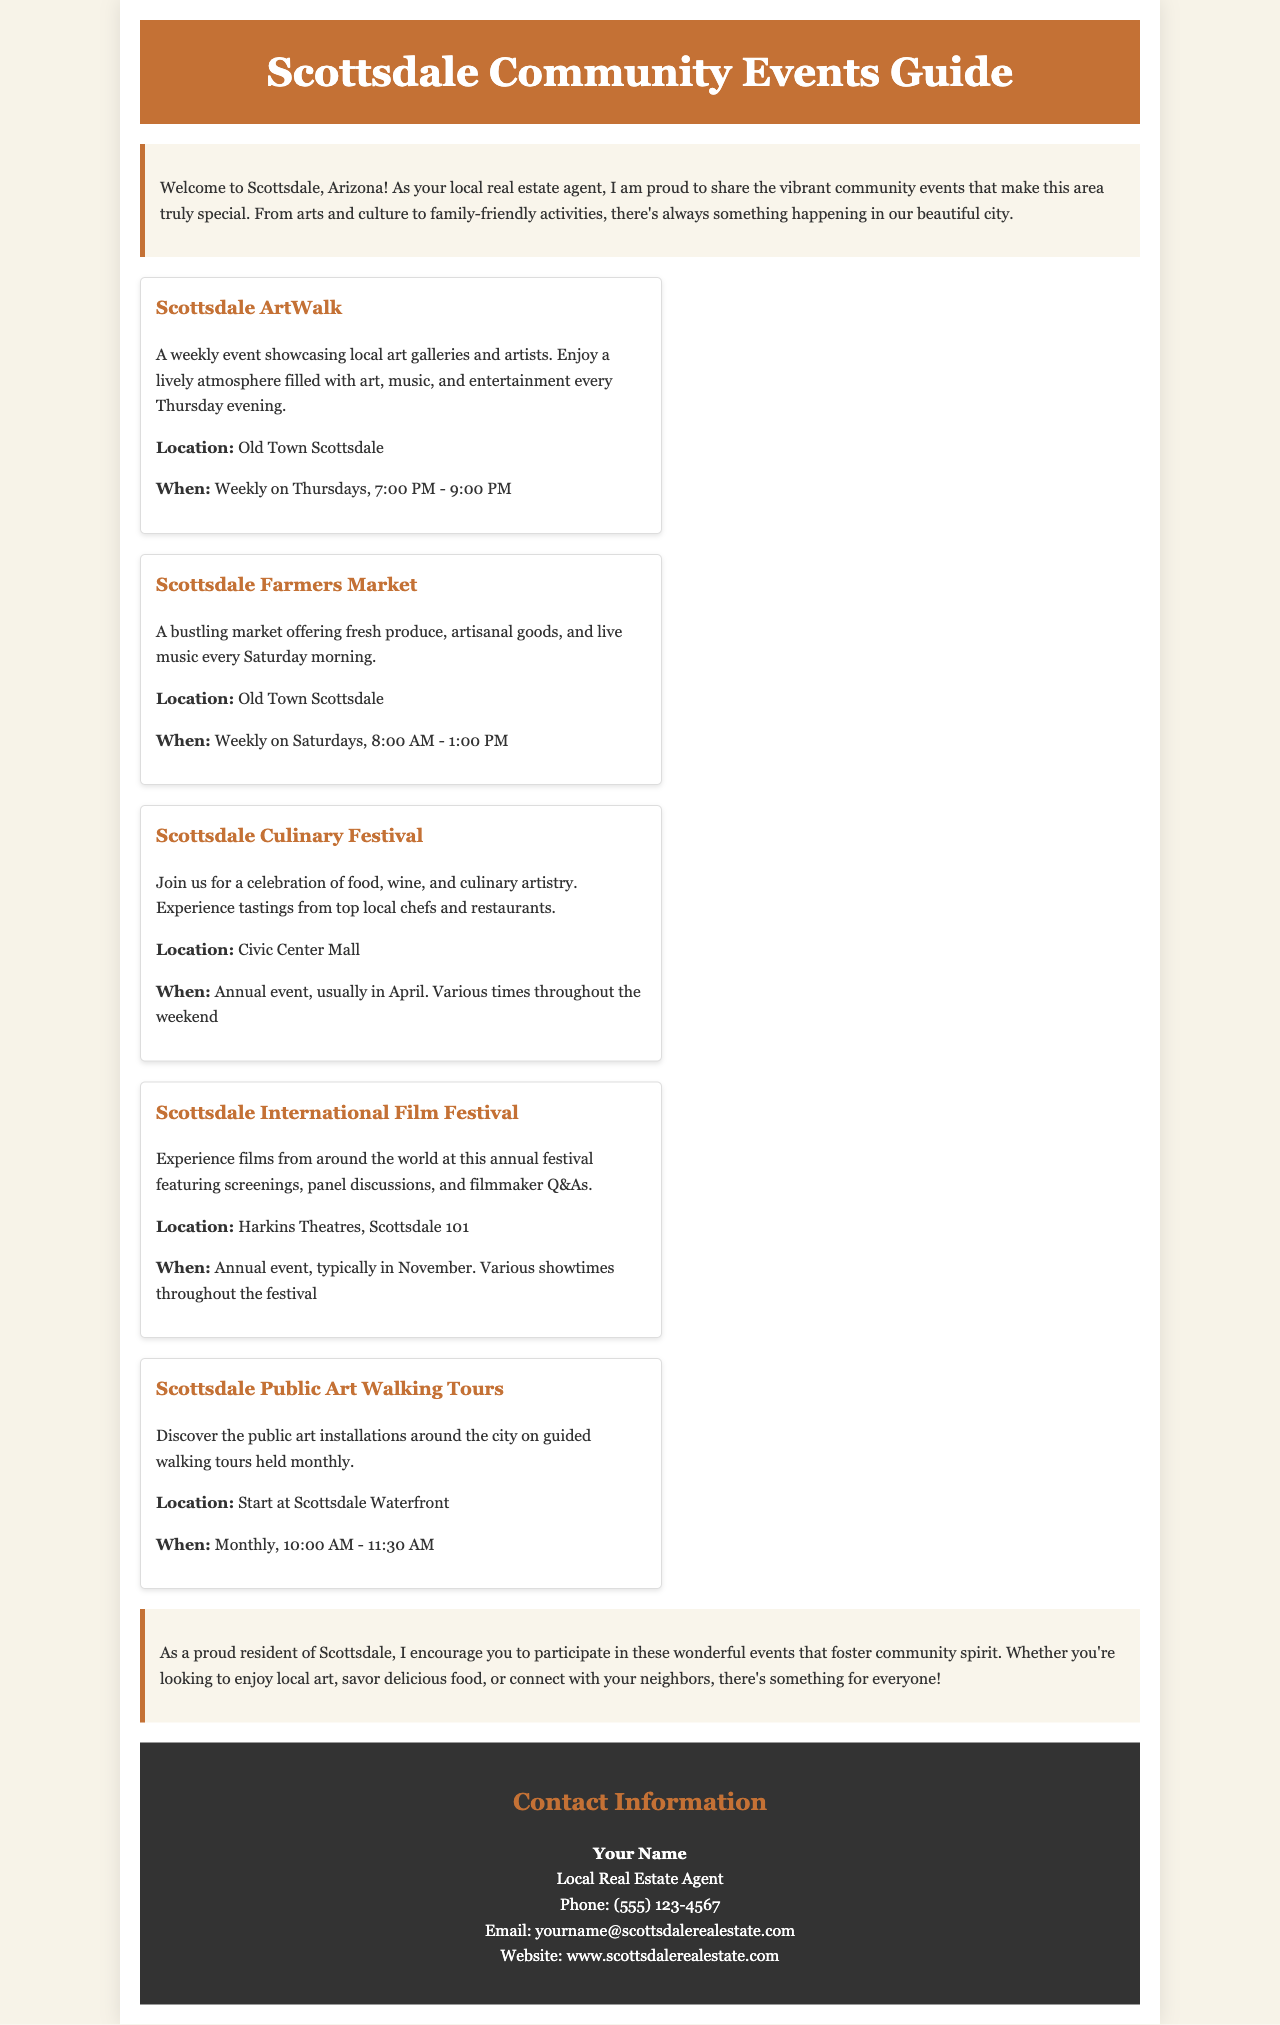What day of the week does the Scottsdale ArtWalk take place? The Scottsdale ArtWalk is held every Thursday evening.
Answer: Thursday What is the location of the Scottsdale Farmers Market? The Farmers Market is located in Old Town Scottsdale.
Answer: Old Town Scottsdale When is the Scottsdale Culinary Festival typically held? The Culinary Festival is an annual event, usually in April.
Answer: April What time does the Scottsdale Public Art Walking Tours start? The walking tours start at 10:00 AM.
Answer: 10:00 AM What type of event is the Scottsdale International Film Festival? The Film Festival features screenings, panel discussions, and filmmaker Q&As.
Answer: Film Festival How often are the Scottsdale Public Art Walking Tours held? The walking tours are held monthly.
Answer: Monthly What is the contact phone number listed in the brochure? The phone number provided is (555) 123-4567.
Answer: (555) 123-4567 What is emphasized in the community involvement section of the brochure? The importance of participating in community events is emphasized.
Answer: Community spirit Where do the guided walking tours start? The tours start at the Scottsdale Waterfront.
Answer: Scottsdale Waterfront 